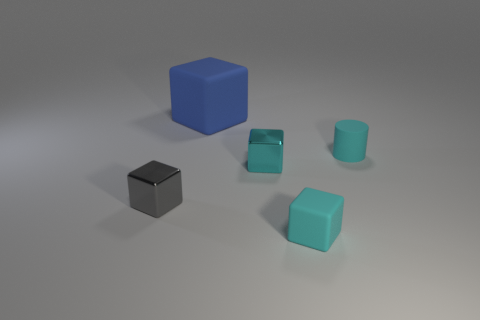Add 5 big blue rubber cylinders. How many objects exist? 10 Subtract all tiny cubes. How many cubes are left? 1 Subtract all blocks. How many objects are left? 1 Subtract 1 cylinders. How many cylinders are left? 0 Subtract all gray cubes. How many cubes are left? 3 Add 4 large brown rubber balls. How many large brown rubber balls exist? 4 Subtract 1 gray blocks. How many objects are left? 4 Subtract all blue cylinders. Subtract all red cubes. How many cylinders are left? 1 Subtract all red cubes. How many green cylinders are left? 0 Subtract all big green rubber cylinders. Subtract all big blue rubber things. How many objects are left? 4 